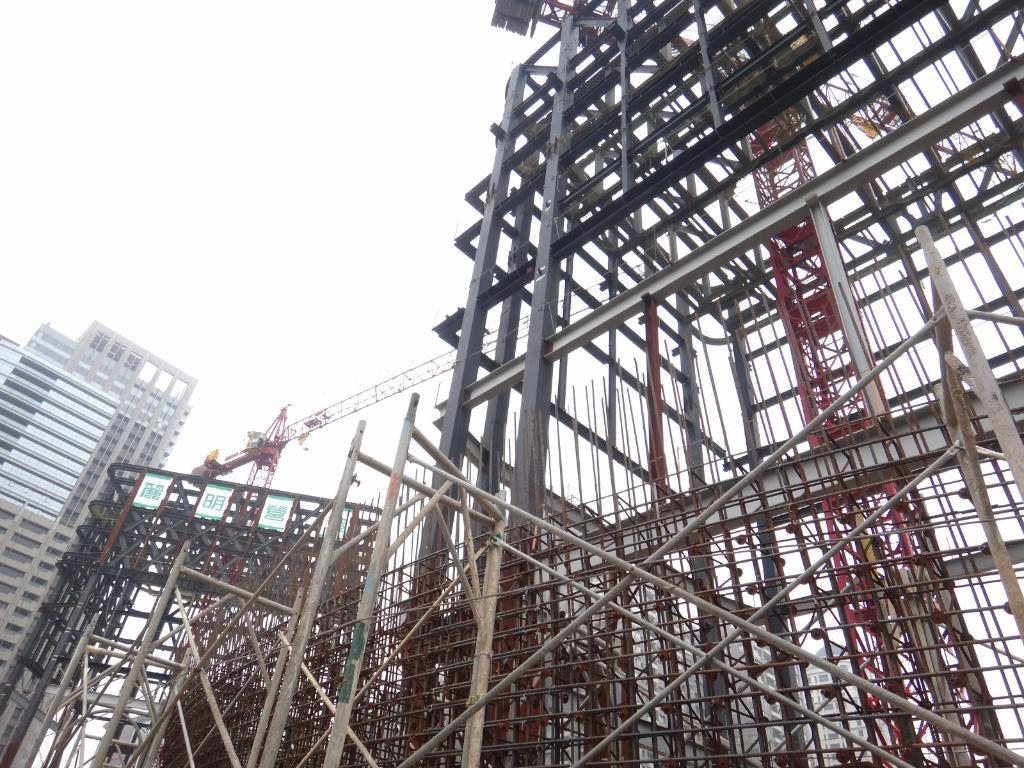What objects are located in the front of the image? There are metal rods in the front of the image. What structure is on the left side of the image? There is a building on the left side of the image. How many boards are on the left side of the image? There are three boards on the left side of the image. What is visible at the top of the image? The sky is visible at the top of the image. Who is the owner of the earth in the image? There is no reference to the earth or any ownership in the image. 